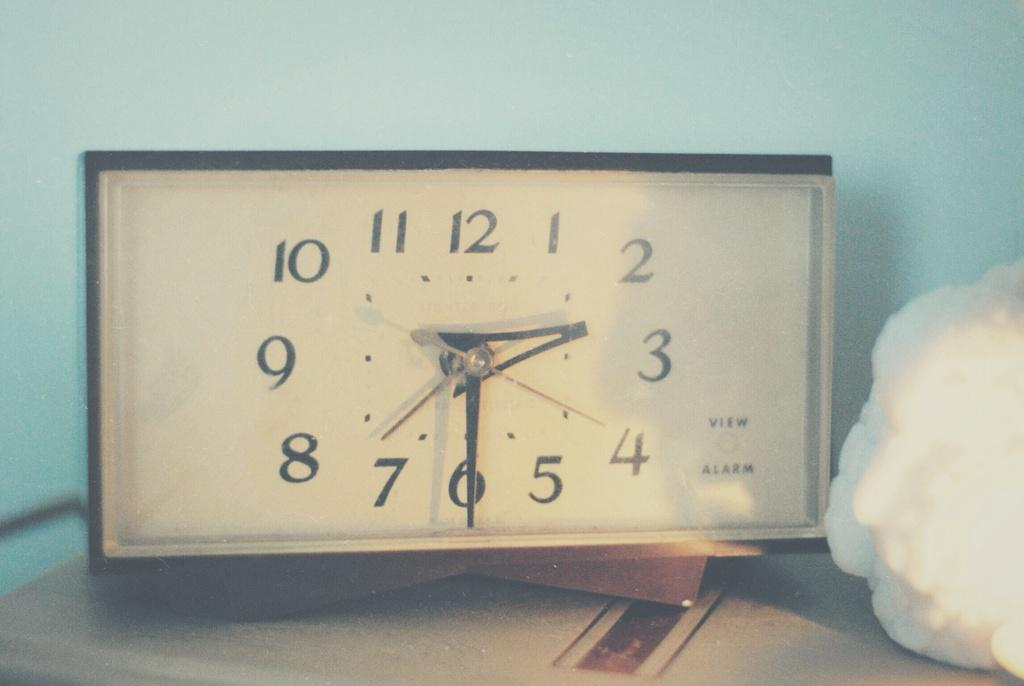Provide a one-sentence caption for the provided image. The alarm is set for 2:30 and set on the table. 